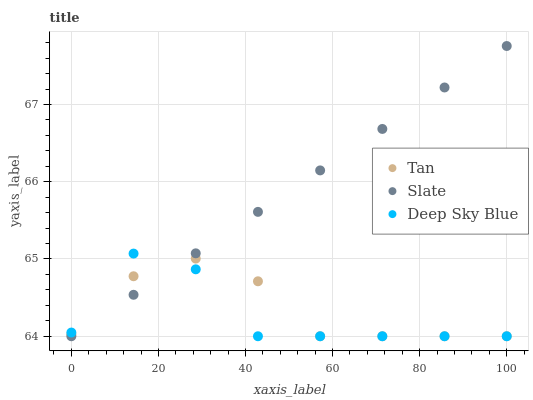Does Deep Sky Blue have the minimum area under the curve?
Answer yes or no. Yes. Does Slate have the maximum area under the curve?
Answer yes or no. Yes. Does Slate have the minimum area under the curve?
Answer yes or no. No. Does Deep Sky Blue have the maximum area under the curve?
Answer yes or no. No. Is Slate the smoothest?
Answer yes or no. Yes. Is Deep Sky Blue the roughest?
Answer yes or no. Yes. Is Deep Sky Blue the smoothest?
Answer yes or no. No. Is Slate the roughest?
Answer yes or no. No. Does Tan have the lowest value?
Answer yes or no. Yes. Does Slate have the highest value?
Answer yes or no. Yes. Does Deep Sky Blue have the highest value?
Answer yes or no. No. Does Tan intersect Slate?
Answer yes or no. Yes. Is Tan less than Slate?
Answer yes or no. No. Is Tan greater than Slate?
Answer yes or no. No. 